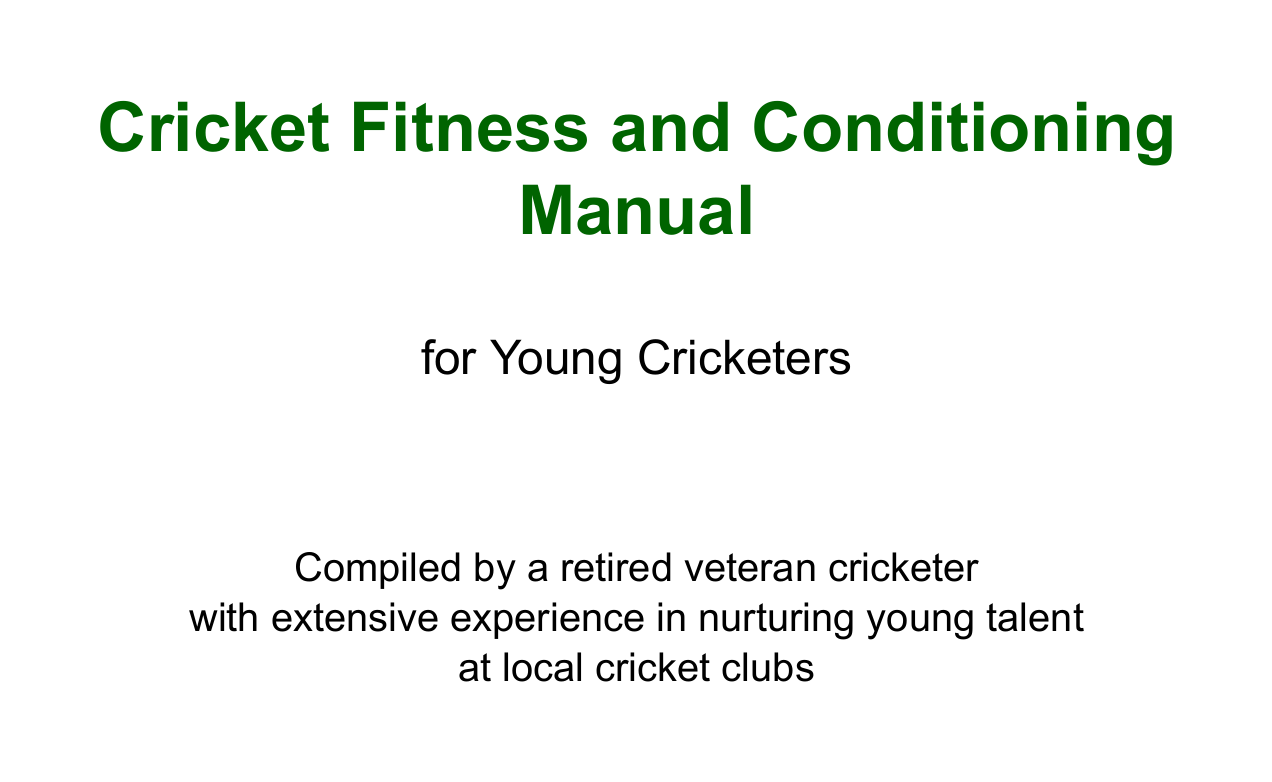What is the title of the manual? The title is found at the beginning of the document in large font.
Answer: Cricket Fitness and Conditioning Manual for Young Cricketers Who compiled the manual? The author's introduction section specifies who compiled the manual.
Answer: A retired veteran cricketer What is the first chapter about? The chapters are listed in a sequential order, and the first chapter title indicates its content.
Answer: Introduction to Cricket-Specific Fitness Name one exercise listed under sample exercises. The sample exercises section provides examples of specific drills included in the manual.
Answer: The Virat Kohli Sprint What is one of the fitness tests mentioned? Fitness tests are outlined in their respective section, giving examples of how performance is measured.
Answer: Beep test for aerobic endurance Which equipment is recommended for training? The recommended equipment section lists items that can be used during exercises.
Answer: Resistance bands What does the manual say about injury prevention? Injury prevention techniques are discussed in the warm-up and flexibility section, indicating its importance.
Answer: Injury prevention techniques How many key physical attributes are mentioned in the introduction chapter? The introduction chapter lists key physical attributes necessary for successful cricketers.
Answer: Three What is the difficulty level of Dhoni's Keeper Squat? The sample exercises section specifies the difficulty level for each listed exercise.
Answer: Beginner 